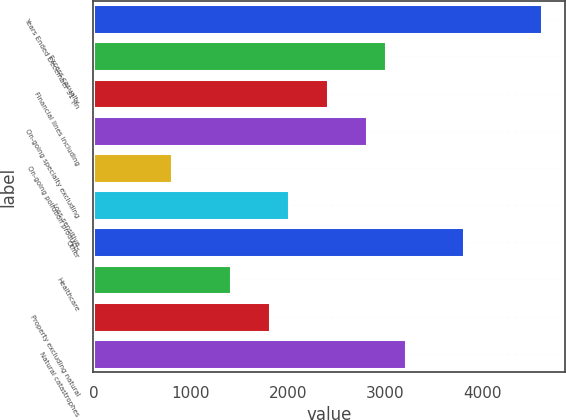Convert chart. <chart><loc_0><loc_0><loc_500><loc_500><bar_chart><fcel>Years Ended December 31 (in<fcel>Excess casualty<fcel>Financial lines including<fcel>On-going specialty excluding<fcel>On-going pollution products<fcel>Loss-sensitive<fcel>Other<fcel>Healthcare<fcel>Property excluding natural<fcel>Natural catastrophes<nl><fcel>4616.9<fcel>3014.5<fcel>2413.6<fcel>2814.2<fcel>811.2<fcel>2013<fcel>3815.7<fcel>1412.1<fcel>1812.7<fcel>3214.8<nl></chart> 